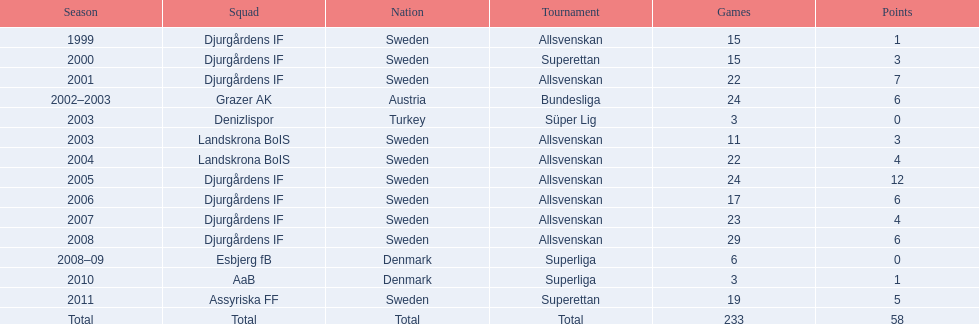What is the total number of matches? 233. Write the full table. {'header': ['Season', 'Squad', 'Nation', 'Tournament', 'Games', 'Points'], 'rows': [['1999', 'Djurgårdens IF', 'Sweden', 'Allsvenskan', '15', '1'], ['2000', 'Djurgårdens IF', 'Sweden', 'Superettan', '15', '3'], ['2001', 'Djurgårdens IF', 'Sweden', 'Allsvenskan', '22', '7'], ['2002–2003', 'Grazer AK', 'Austria', 'Bundesliga', '24', '6'], ['2003', 'Denizlispor', 'Turkey', 'Süper Lig', '3', '0'], ['2003', 'Landskrona BoIS', 'Sweden', 'Allsvenskan', '11', '3'], ['2004', 'Landskrona BoIS', 'Sweden', 'Allsvenskan', '22', '4'], ['2005', 'Djurgårdens IF', 'Sweden', 'Allsvenskan', '24', '12'], ['2006', 'Djurgårdens IF', 'Sweden', 'Allsvenskan', '17', '6'], ['2007', 'Djurgårdens IF', 'Sweden', 'Allsvenskan', '23', '4'], ['2008', 'Djurgårdens IF', 'Sweden', 'Allsvenskan', '29', '6'], ['2008–09', 'Esbjerg fB', 'Denmark', 'Superliga', '6', '0'], ['2010', 'AaB', 'Denmark', 'Superliga', '3', '1'], ['2011', 'Assyriska FF', 'Sweden', 'Superettan', '19', '5'], ['Total', 'Total', 'Total', 'Total', '233', '58']]} 